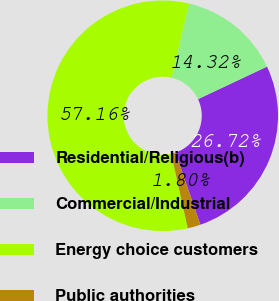Convert chart to OTSL. <chart><loc_0><loc_0><loc_500><loc_500><pie_chart><fcel>Residential/Religious(b)<fcel>Commercial/Industrial<fcel>Energy choice customers<fcel>Public authorities<nl><fcel>26.72%<fcel>14.32%<fcel>57.15%<fcel>1.8%<nl></chart> 